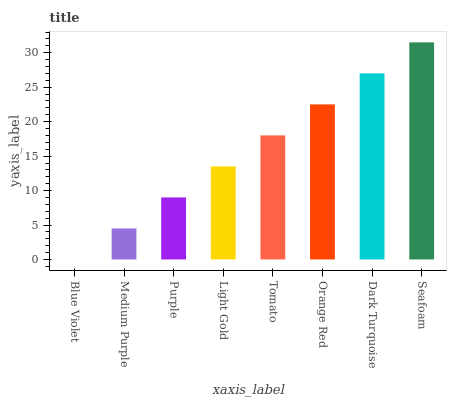Is Blue Violet the minimum?
Answer yes or no. Yes. Is Seafoam the maximum?
Answer yes or no. Yes. Is Medium Purple the minimum?
Answer yes or no. No. Is Medium Purple the maximum?
Answer yes or no. No. Is Medium Purple greater than Blue Violet?
Answer yes or no. Yes. Is Blue Violet less than Medium Purple?
Answer yes or no. Yes. Is Blue Violet greater than Medium Purple?
Answer yes or no. No. Is Medium Purple less than Blue Violet?
Answer yes or no. No. Is Tomato the high median?
Answer yes or no. Yes. Is Light Gold the low median?
Answer yes or no. Yes. Is Purple the high median?
Answer yes or no. No. Is Blue Violet the low median?
Answer yes or no. No. 